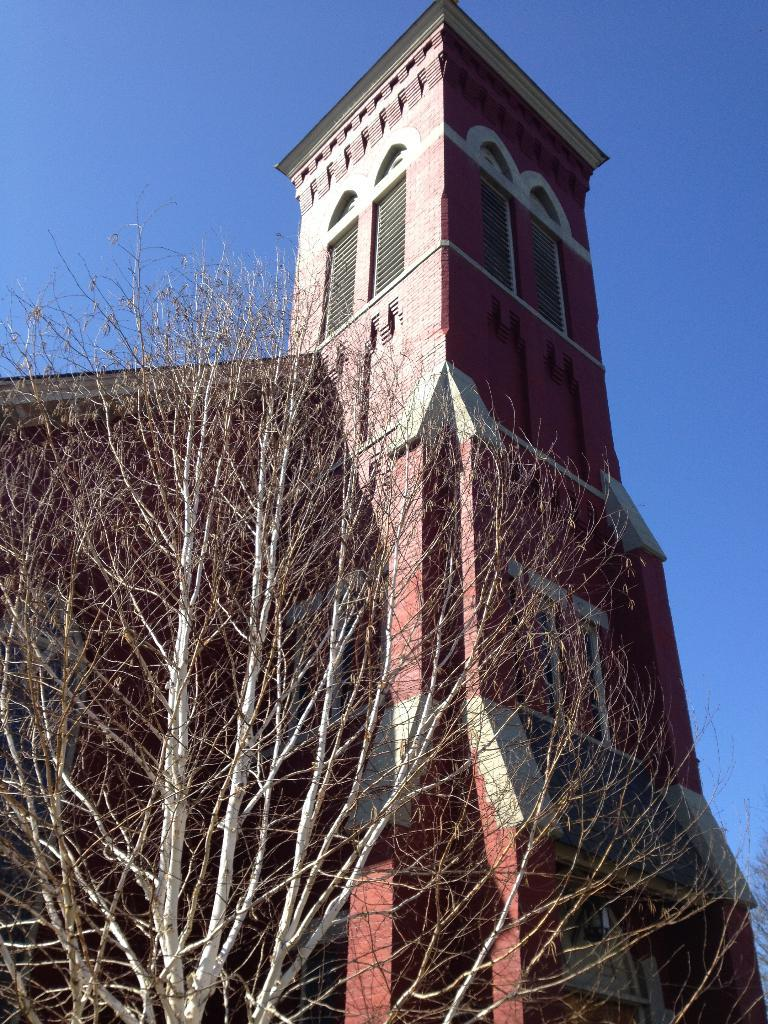What type of natural element is present in the image? There is a tree in the image. What structure can be seen behind the tree? There is a building behind the tree in the image. Where is the tub located in the image? There is no tub present in the image. What type of joke can be seen in the image? There is no joke present in the image. 